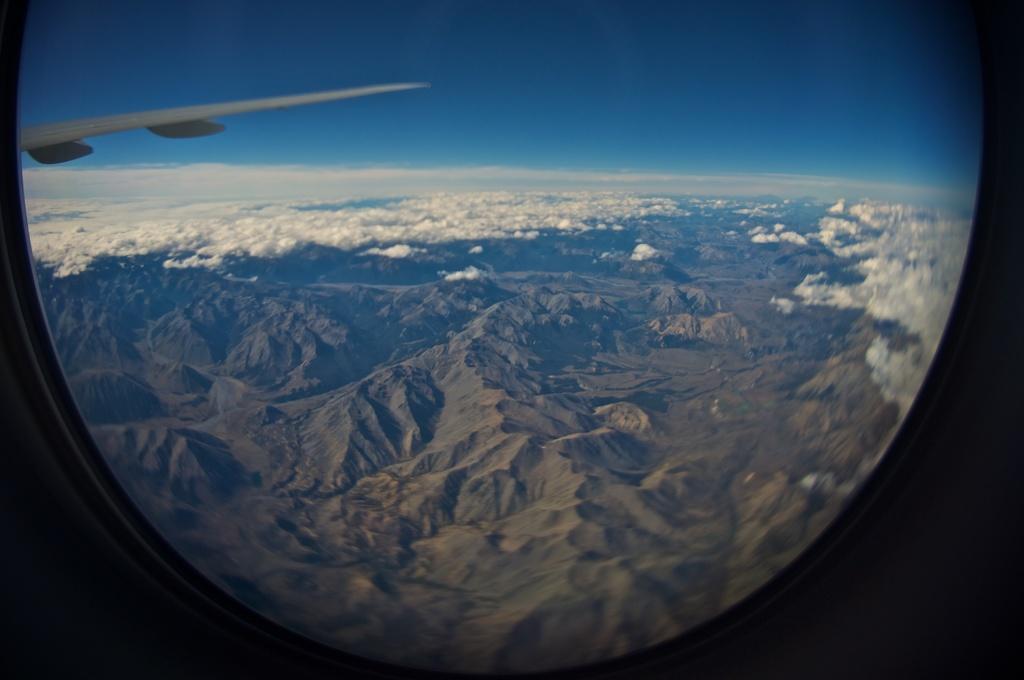In one or two sentences, can you explain what this image depicts? In this image I can see a part of the aircraft. In the background, I can see the mountains and clouds in the sky. 